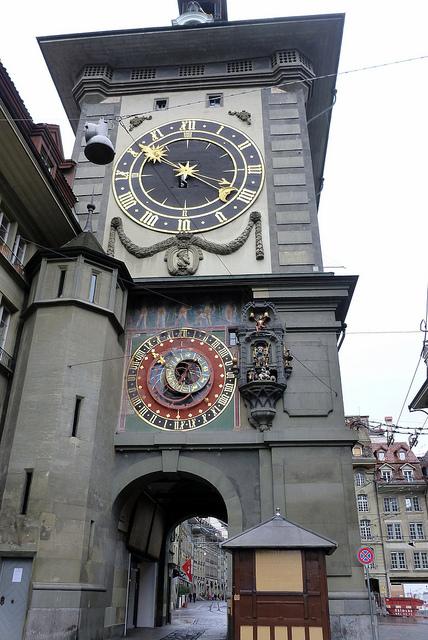Are there any people in the picture?
Give a very brief answer. No. What time is it?
Give a very brief answer. 10:20. Can you walk under the clock?
Concise answer only. Yes. Is this a large building?
Quick response, please. Yes. 